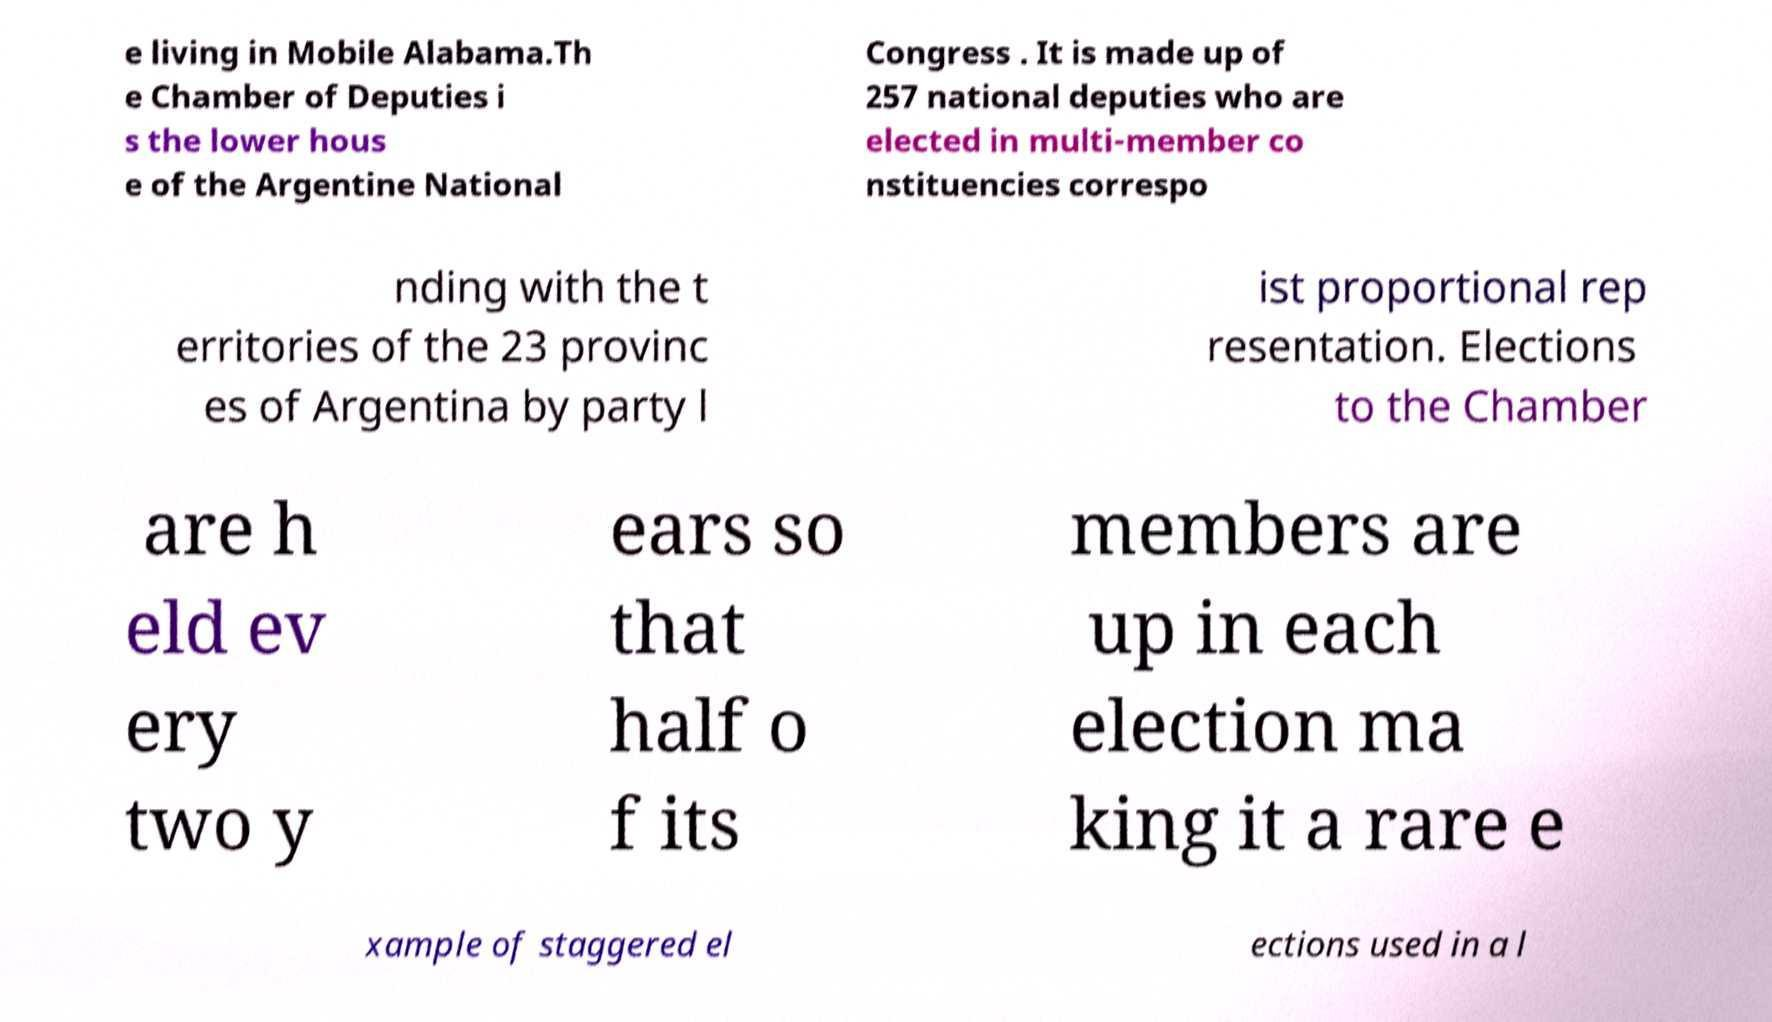Can you read and provide the text displayed in the image?This photo seems to have some interesting text. Can you extract and type it out for me? e living in Mobile Alabama.Th e Chamber of Deputies i s the lower hous e of the Argentine National Congress . It is made up of 257 national deputies who are elected in multi-member co nstituencies correspo nding with the t erritories of the 23 provinc es of Argentina by party l ist proportional rep resentation. Elections to the Chamber are h eld ev ery two y ears so that half o f its members are up in each election ma king it a rare e xample of staggered el ections used in a l 